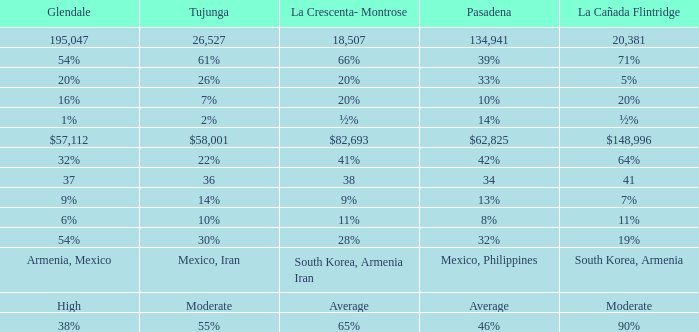What is the figure for Pasadena when Tujunga is 36? 34.0. 